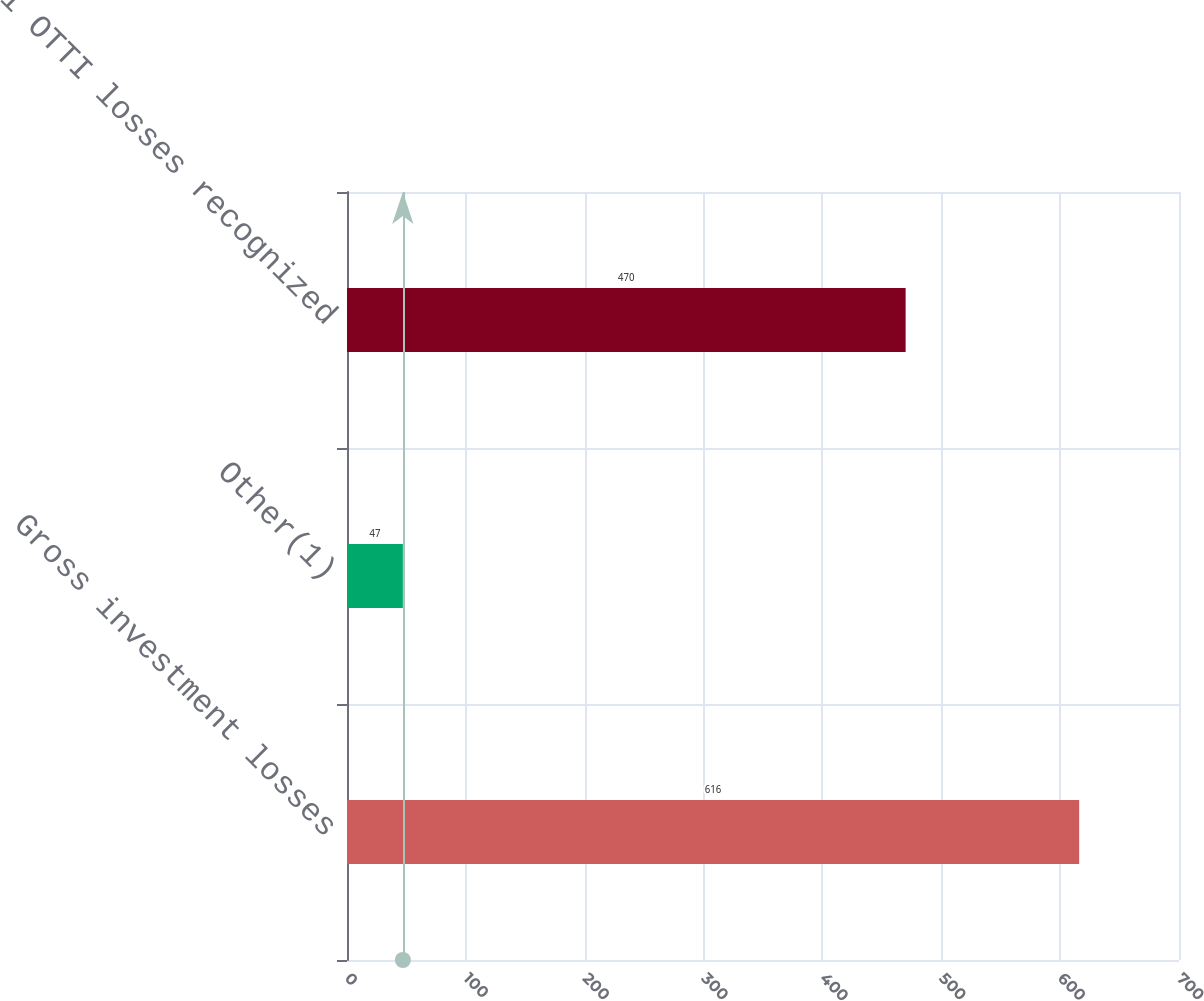Convert chart. <chart><loc_0><loc_0><loc_500><loc_500><bar_chart><fcel>Gross investment losses<fcel>Other(1)<fcel>Total OTTI losses recognized<nl><fcel>616<fcel>47<fcel>470<nl></chart> 